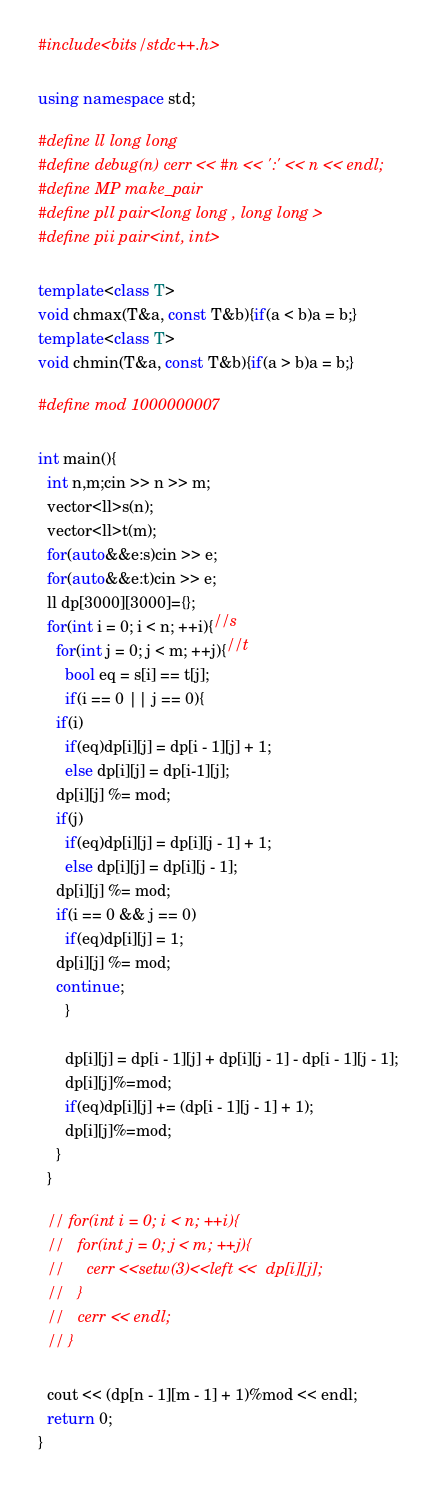Convert code to text. <code><loc_0><loc_0><loc_500><loc_500><_C++_>#include<bits/stdc++.h>

using namespace std;

#define ll long long
#define debug(n) cerr << #n << ':' << n << endl;
#define MP make_pair
#define pll pair<long long , long long >
#define pii pair<int, int>

template<class T>
void chmax(T&a, const T&b){if(a < b)a = b;}
template<class T>
void chmin(T&a, const T&b){if(a > b)a = b;}

#define mod 1000000007

int main(){
  int n,m;cin >> n >> m;
  vector<ll>s(n);
  vector<ll>t(m);
  for(auto&&e:s)cin >> e;
  for(auto&&e:t)cin >> e;
  ll dp[3000][3000]={};
  for(int i = 0; i < n; ++i){//s
    for(int j = 0; j < m; ++j){//t
      bool eq = s[i] == t[j];
      if(i == 0 || j == 0){
	if(i)
	  if(eq)dp[i][j] = dp[i - 1][j] + 1;
	  else dp[i][j] = dp[i-1][j];
	dp[i][j] %= mod;
	if(j)
	  if(eq)dp[i][j] = dp[i][j - 1] + 1;
	  else dp[i][j] = dp[i][j - 1];
	dp[i][j] %= mod;	  
	if(i == 0 && j == 0)
	  if(eq)dp[i][j] = 1;
	dp[i][j] %= mod;
	continue;
      }

      dp[i][j] = dp[i - 1][j] + dp[i][j - 1] - dp[i - 1][j - 1];
      dp[i][j]%=mod;      
      if(eq)dp[i][j] += (dp[i - 1][j - 1] + 1);
      dp[i][j]%=mod;      
    }
  }

  // for(int i = 0; i < n; ++i){
  //   for(int j = 0; j < m; ++j){
  //     cerr <<setw(3)<<left <<  dp[i][j];
  //   }
  //   cerr << endl;
  // }
  
  cout << (dp[n - 1][m - 1] + 1)%mod << endl;
  return 0;
}
</code> 